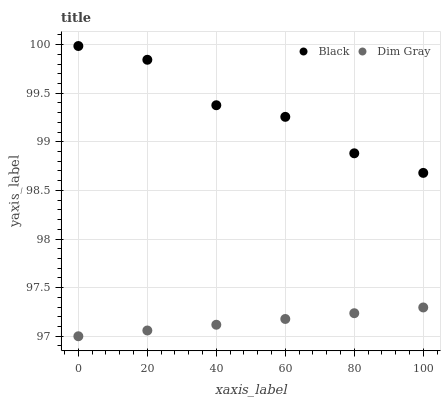Does Dim Gray have the minimum area under the curve?
Answer yes or no. Yes. Does Black have the maximum area under the curve?
Answer yes or no. Yes. Does Black have the minimum area under the curve?
Answer yes or no. No. Is Dim Gray the smoothest?
Answer yes or no. Yes. Is Black the roughest?
Answer yes or no. Yes. Is Black the smoothest?
Answer yes or no. No. Does Dim Gray have the lowest value?
Answer yes or no. Yes. Does Black have the lowest value?
Answer yes or no. No. Does Black have the highest value?
Answer yes or no. Yes. Is Dim Gray less than Black?
Answer yes or no. Yes. Is Black greater than Dim Gray?
Answer yes or no. Yes. Does Dim Gray intersect Black?
Answer yes or no. No. 